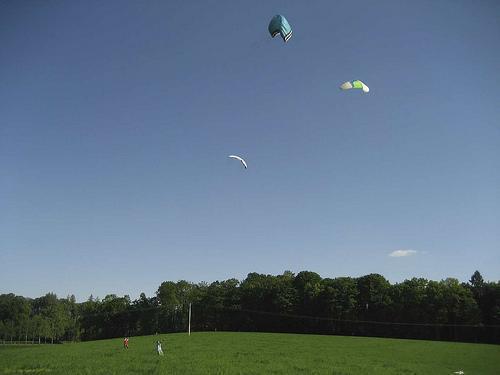How many objects are flying in the sky?
Give a very brief answer. 3. 